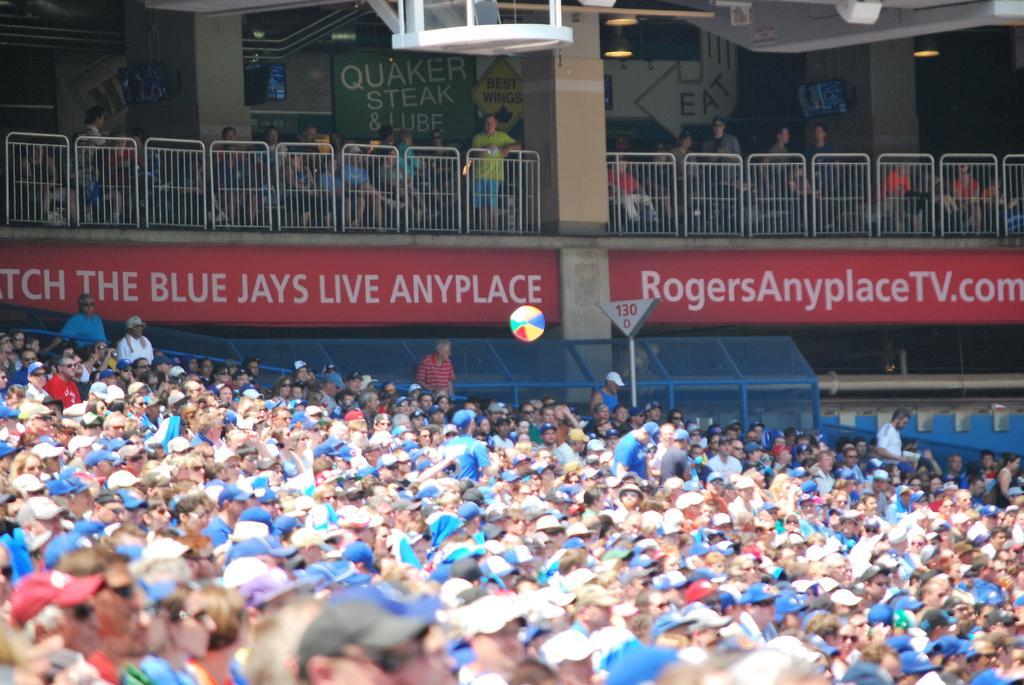In one or two sentences, can you explain what this image depicts? In this image we can see people sitting on the chairs and standing on the floor in a stadium, electric lights, railings and information boards. 